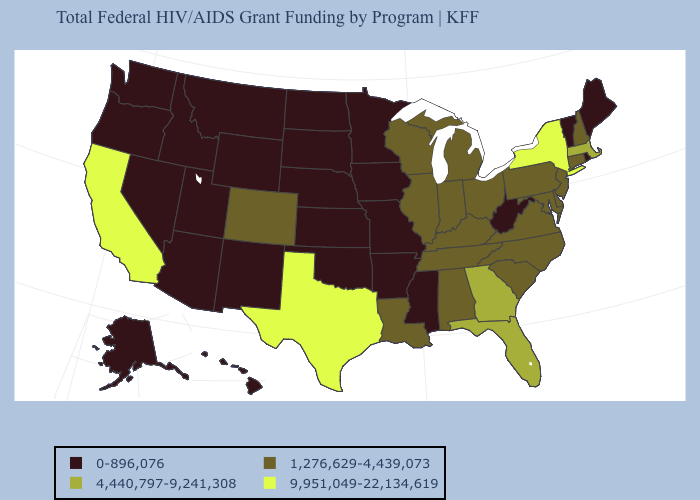Name the states that have a value in the range 0-896,076?
Write a very short answer. Alaska, Arizona, Arkansas, Hawaii, Idaho, Iowa, Kansas, Maine, Minnesota, Mississippi, Missouri, Montana, Nebraska, Nevada, New Mexico, North Dakota, Oklahoma, Oregon, Rhode Island, South Dakota, Utah, Vermont, Washington, West Virginia, Wyoming. What is the lowest value in the West?
Answer briefly. 0-896,076. Among the states that border Connecticut , which have the highest value?
Be succinct. New York. Does Texas have the highest value in the USA?
Short answer required. Yes. Does Texas have the highest value in the South?
Be succinct. Yes. Does the first symbol in the legend represent the smallest category?
Concise answer only. Yes. What is the lowest value in states that border New York?
Concise answer only. 0-896,076. Name the states that have a value in the range 9,951,049-22,134,619?
Write a very short answer. California, New York, Texas. What is the lowest value in the USA?
Short answer required. 0-896,076. Does the map have missing data?
Concise answer only. No. Does Mississippi have a lower value than Hawaii?
Be succinct. No. What is the value of South Carolina?
Be succinct. 1,276,629-4,439,073. Which states hav the highest value in the South?
Keep it brief. Texas. Is the legend a continuous bar?
Give a very brief answer. No. 